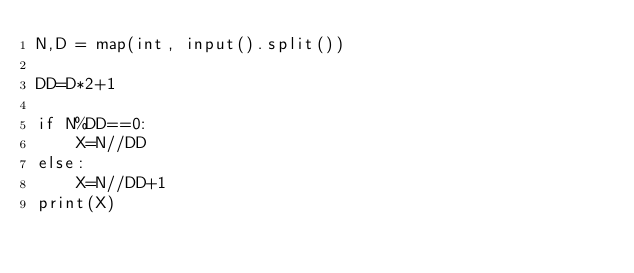Convert code to text. <code><loc_0><loc_0><loc_500><loc_500><_Python_>N,D = map(int, input().split())

DD=D*2+1

if N%DD==0:
    X=N//DD
else:
    X=N//DD+1
print(X)

</code> 